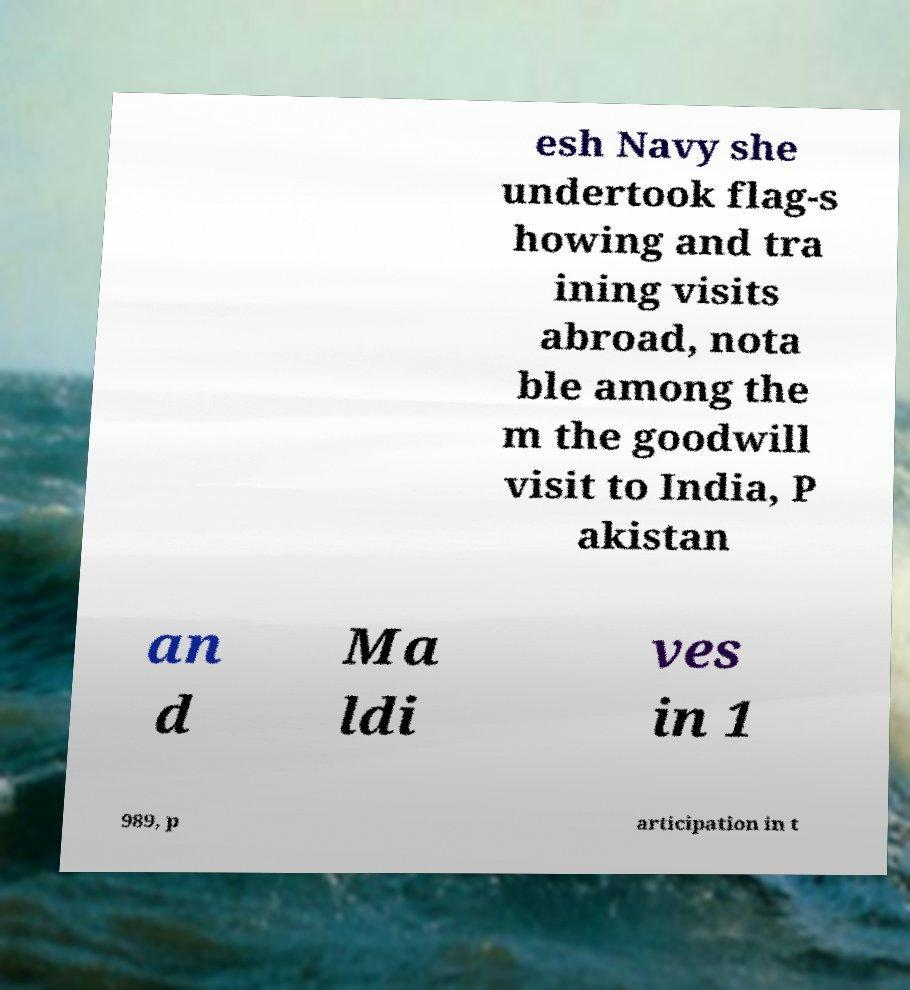For documentation purposes, I need the text within this image transcribed. Could you provide that? esh Navy she undertook flag-s howing and tra ining visits abroad, nota ble among the m the goodwill visit to India, P akistan an d Ma ldi ves in 1 989, p articipation in t 